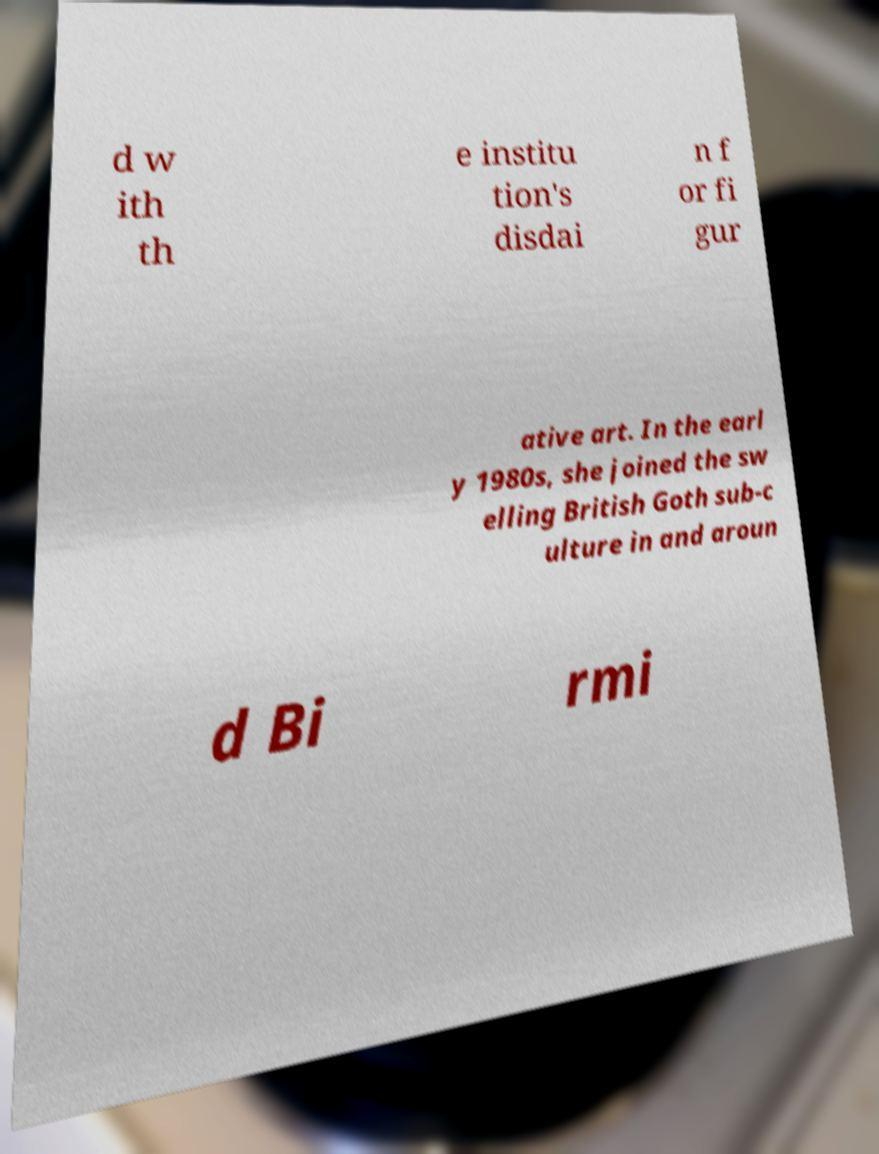Please identify and transcribe the text found in this image. d w ith th e institu tion's disdai n f or fi gur ative art. In the earl y 1980s, she joined the sw elling British Goth sub-c ulture in and aroun d Bi rmi 